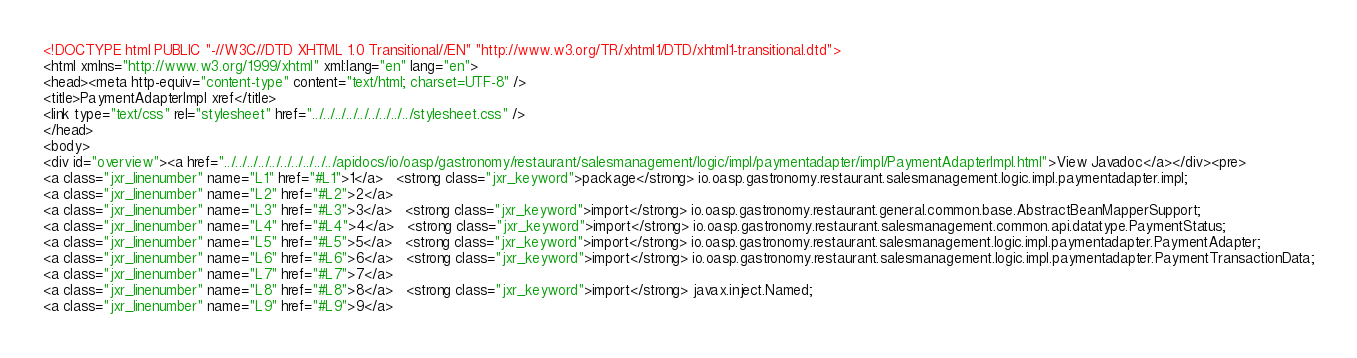Convert code to text. <code><loc_0><loc_0><loc_500><loc_500><_HTML_><!DOCTYPE html PUBLIC "-//W3C//DTD XHTML 1.0 Transitional//EN" "http://www.w3.org/TR/xhtml1/DTD/xhtml1-transitional.dtd">
<html xmlns="http://www.w3.org/1999/xhtml" xml:lang="en" lang="en">
<head><meta http-equiv="content-type" content="text/html; charset=UTF-8" />
<title>PaymentAdapterImpl xref</title>
<link type="text/css" rel="stylesheet" href="../../../../../../../../../stylesheet.css" />
</head>
<body>
<div id="overview"><a href="../../../../../../../../../../apidocs/io/oasp/gastronomy/restaurant/salesmanagement/logic/impl/paymentadapter/impl/PaymentAdapterImpl.html">View Javadoc</a></div><pre>
<a class="jxr_linenumber" name="L1" href="#L1">1</a>   <strong class="jxr_keyword">package</strong> io.oasp.gastronomy.restaurant.salesmanagement.logic.impl.paymentadapter.impl;
<a class="jxr_linenumber" name="L2" href="#L2">2</a>   
<a class="jxr_linenumber" name="L3" href="#L3">3</a>   <strong class="jxr_keyword">import</strong> io.oasp.gastronomy.restaurant.general.common.base.AbstractBeanMapperSupport;
<a class="jxr_linenumber" name="L4" href="#L4">4</a>   <strong class="jxr_keyword">import</strong> io.oasp.gastronomy.restaurant.salesmanagement.common.api.datatype.PaymentStatus;
<a class="jxr_linenumber" name="L5" href="#L5">5</a>   <strong class="jxr_keyword">import</strong> io.oasp.gastronomy.restaurant.salesmanagement.logic.impl.paymentadapter.PaymentAdapter;
<a class="jxr_linenumber" name="L6" href="#L6">6</a>   <strong class="jxr_keyword">import</strong> io.oasp.gastronomy.restaurant.salesmanagement.logic.impl.paymentadapter.PaymentTransactionData;
<a class="jxr_linenumber" name="L7" href="#L7">7</a>   
<a class="jxr_linenumber" name="L8" href="#L8">8</a>   <strong class="jxr_keyword">import</strong> javax.inject.Named;
<a class="jxr_linenumber" name="L9" href="#L9">9</a>   </code> 